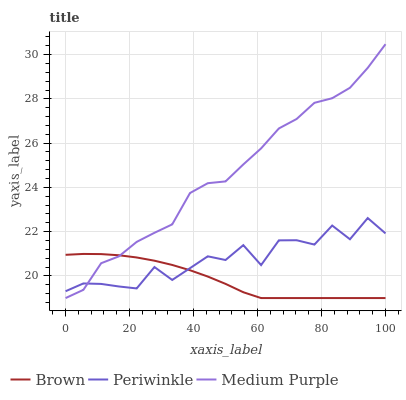Does Brown have the minimum area under the curve?
Answer yes or no. Yes. Does Medium Purple have the maximum area under the curve?
Answer yes or no. Yes. Does Periwinkle have the minimum area under the curve?
Answer yes or no. No. Does Periwinkle have the maximum area under the curve?
Answer yes or no. No. Is Brown the smoothest?
Answer yes or no. Yes. Is Periwinkle the roughest?
Answer yes or no. Yes. Is Periwinkle the smoothest?
Answer yes or no. No. Is Brown the roughest?
Answer yes or no. No. Does Medium Purple have the lowest value?
Answer yes or no. Yes. Does Periwinkle have the lowest value?
Answer yes or no. No. Does Medium Purple have the highest value?
Answer yes or no. Yes. Does Periwinkle have the highest value?
Answer yes or no. No. Does Medium Purple intersect Brown?
Answer yes or no. Yes. Is Medium Purple less than Brown?
Answer yes or no. No. Is Medium Purple greater than Brown?
Answer yes or no. No. 